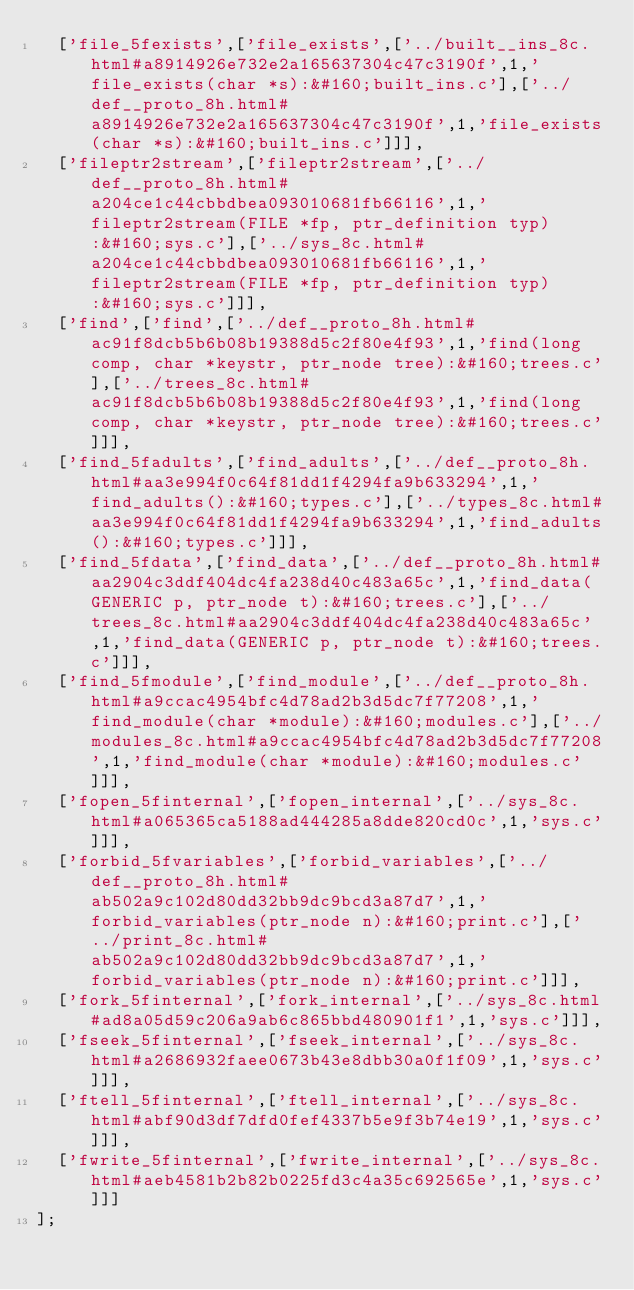Convert code to text. <code><loc_0><loc_0><loc_500><loc_500><_JavaScript_>  ['file_5fexists',['file_exists',['../built__ins_8c.html#a8914926e732e2a165637304c47c3190f',1,'file_exists(char *s):&#160;built_ins.c'],['../def__proto_8h.html#a8914926e732e2a165637304c47c3190f',1,'file_exists(char *s):&#160;built_ins.c']]],
  ['fileptr2stream',['fileptr2stream',['../def__proto_8h.html#a204ce1c44cbbdbea093010681fb66116',1,'fileptr2stream(FILE *fp, ptr_definition typ):&#160;sys.c'],['../sys_8c.html#a204ce1c44cbbdbea093010681fb66116',1,'fileptr2stream(FILE *fp, ptr_definition typ):&#160;sys.c']]],
  ['find',['find',['../def__proto_8h.html#ac91f8dcb5b6b08b19388d5c2f80e4f93',1,'find(long comp, char *keystr, ptr_node tree):&#160;trees.c'],['../trees_8c.html#ac91f8dcb5b6b08b19388d5c2f80e4f93',1,'find(long comp, char *keystr, ptr_node tree):&#160;trees.c']]],
  ['find_5fadults',['find_adults',['../def__proto_8h.html#aa3e994f0c64f81dd1f4294fa9b633294',1,'find_adults():&#160;types.c'],['../types_8c.html#aa3e994f0c64f81dd1f4294fa9b633294',1,'find_adults():&#160;types.c']]],
  ['find_5fdata',['find_data',['../def__proto_8h.html#aa2904c3ddf404dc4fa238d40c483a65c',1,'find_data(GENERIC p, ptr_node t):&#160;trees.c'],['../trees_8c.html#aa2904c3ddf404dc4fa238d40c483a65c',1,'find_data(GENERIC p, ptr_node t):&#160;trees.c']]],
  ['find_5fmodule',['find_module',['../def__proto_8h.html#a9ccac4954bfc4d78ad2b3d5dc7f77208',1,'find_module(char *module):&#160;modules.c'],['../modules_8c.html#a9ccac4954bfc4d78ad2b3d5dc7f77208',1,'find_module(char *module):&#160;modules.c']]],
  ['fopen_5finternal',['fopen_internal',['../sys_8c.html#a065365ca5188ad444285a8dde820cd0c',1,'sys.c']]],
  ['forbid_5fvariables',['forbid_variables',['../def__proto_8h.html#ab502a9c102d80dd32bb9dc9bcd3a87d7',1,'forbid_variables(ptr_node n):&#160;print.c'],['../print_8c.html#ab502a9c102d80dd32bb9dc9bcd3a87d7',1,'forbid_variables(ptr_node n):&#160;print.c']]],
  ['fork_5finternal',['fork_internal',['../sys_8c.html#ad8a05d59c206a9ab6c865bbd480901f1',1,'sys.c']]],
  ['fseek_5finternal',['fseek_internal',['../sys_8c.html#a2686932faee0673b43e8dbb30a0f1f09',1,'sys.c']]],
  ['ftell_5finternal',['ftell_internal',['../sys_8c.html#abf90d3df7dfd0fef4337b5e9f3b74e19',1,'sys.c']]],
  ['fwrite_5finternal',['fwrite_internal',['../sys_8c.html#aeb4581b2b82b0225fd3c4a35c692565e',1,'sys.c']]]
];
</code> 